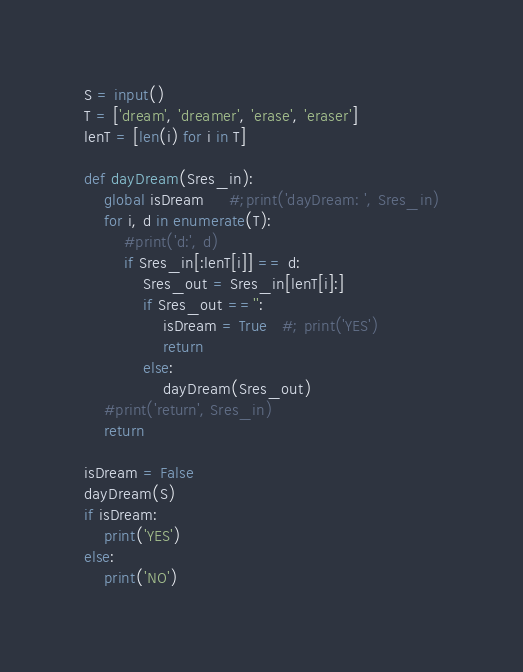<code> <loc_0><loc_0><loc_500><loc_500><_Python_>S = input()
T = ['dream', 'dreamer', 'erase', 'eraser']
lenT = [len(i) for i in T]

def dayDream(Sres_in):
    global isDream     #;print('dayDream: ', Sres_in)
    for i, d in enumerate(T):
        #print('d:', d)
        if Sres_in[:lenT[i]] == d:            
            Sres_out = Sres_in[lenT[i]:]
            if Sres_out =='':                
                isDream = True   #; print('YES')
                return 
            else:
                dayDream(Sres_out)
    #print('return', Sres_in)
    return
    
isDream = False
dayDream(S)
if isDream:
    print('YES')
else:
    print('NO')</code> 